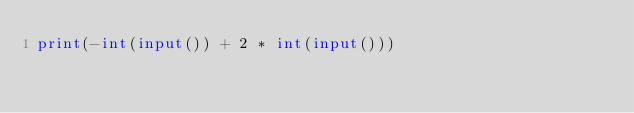Convert code to text. <code><loc_0><loc_0><loc_500><loc_500><_Python_>print(-int(input()) + 2 * int(input()))</code> 